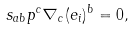Convert formula to latex. <formula><loc_0><loc_0><loc_500><loc_500>s _ { a b } p ^ { c } \nabla _ { c } ( e _ { i } ) ^ { b } = 0 ,</formula> 